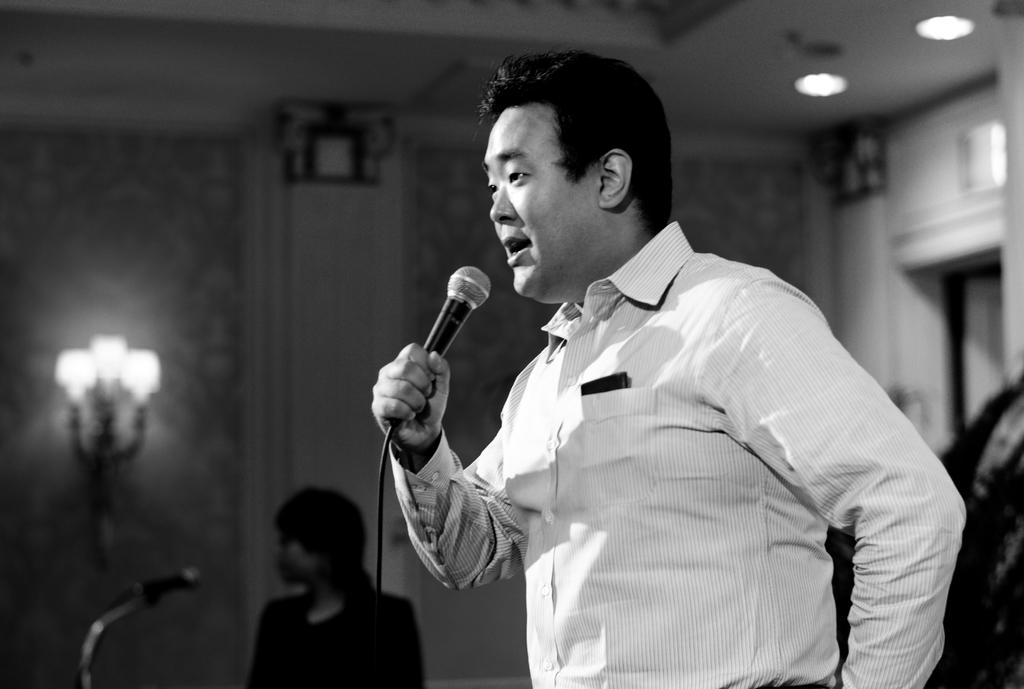What is the person in the image doing? The person is standing and holding a microphone. What can be seen in the background of the image? There is a wall and lights in the background of the image. Are there any other people visible in the image? Yes, there is another person in the background of the image. Where are the lights located in the image? There are lights visible at the top of the image. What type of advertisement is displayed on the page in the image? There is no page or advertisement present in the image. How many bridges can be seen in the image? There are no bridges visible in the image. 